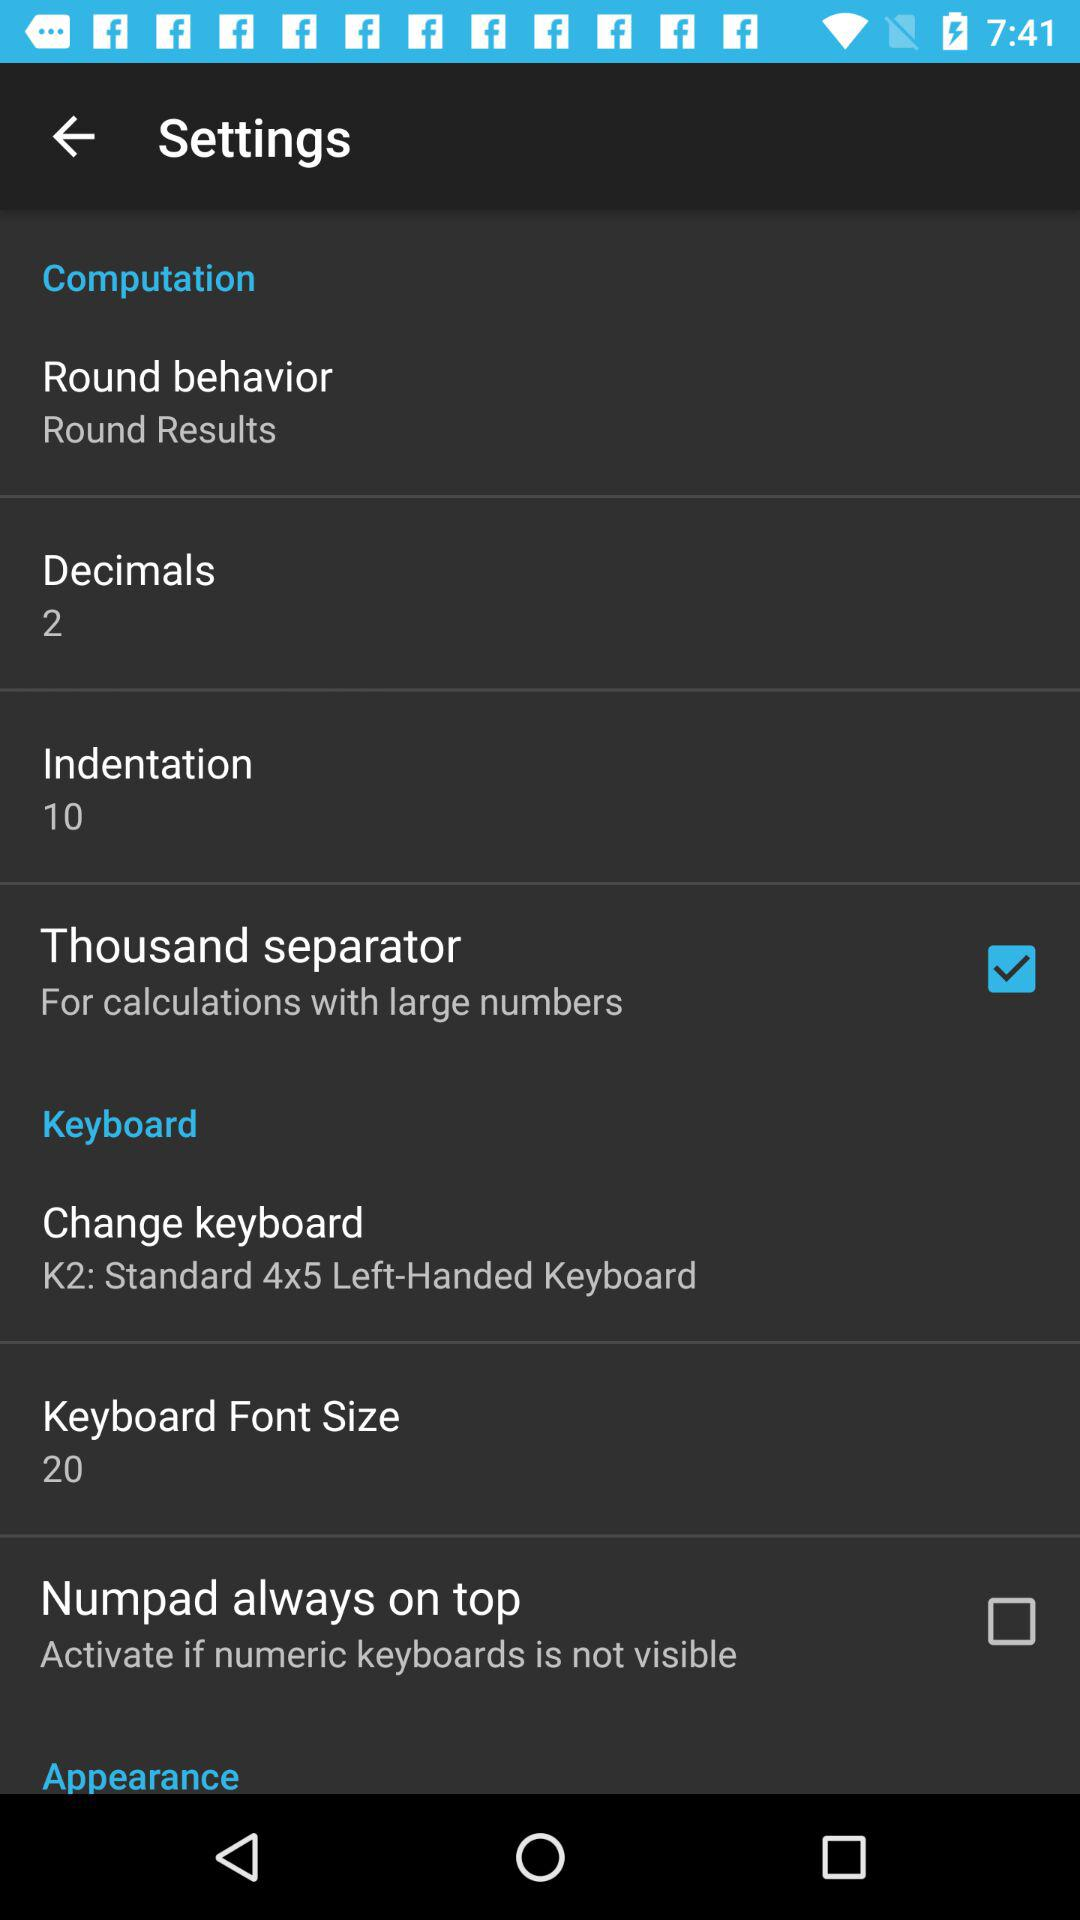What is the status of "Numpad always on top"? The status is "off". 